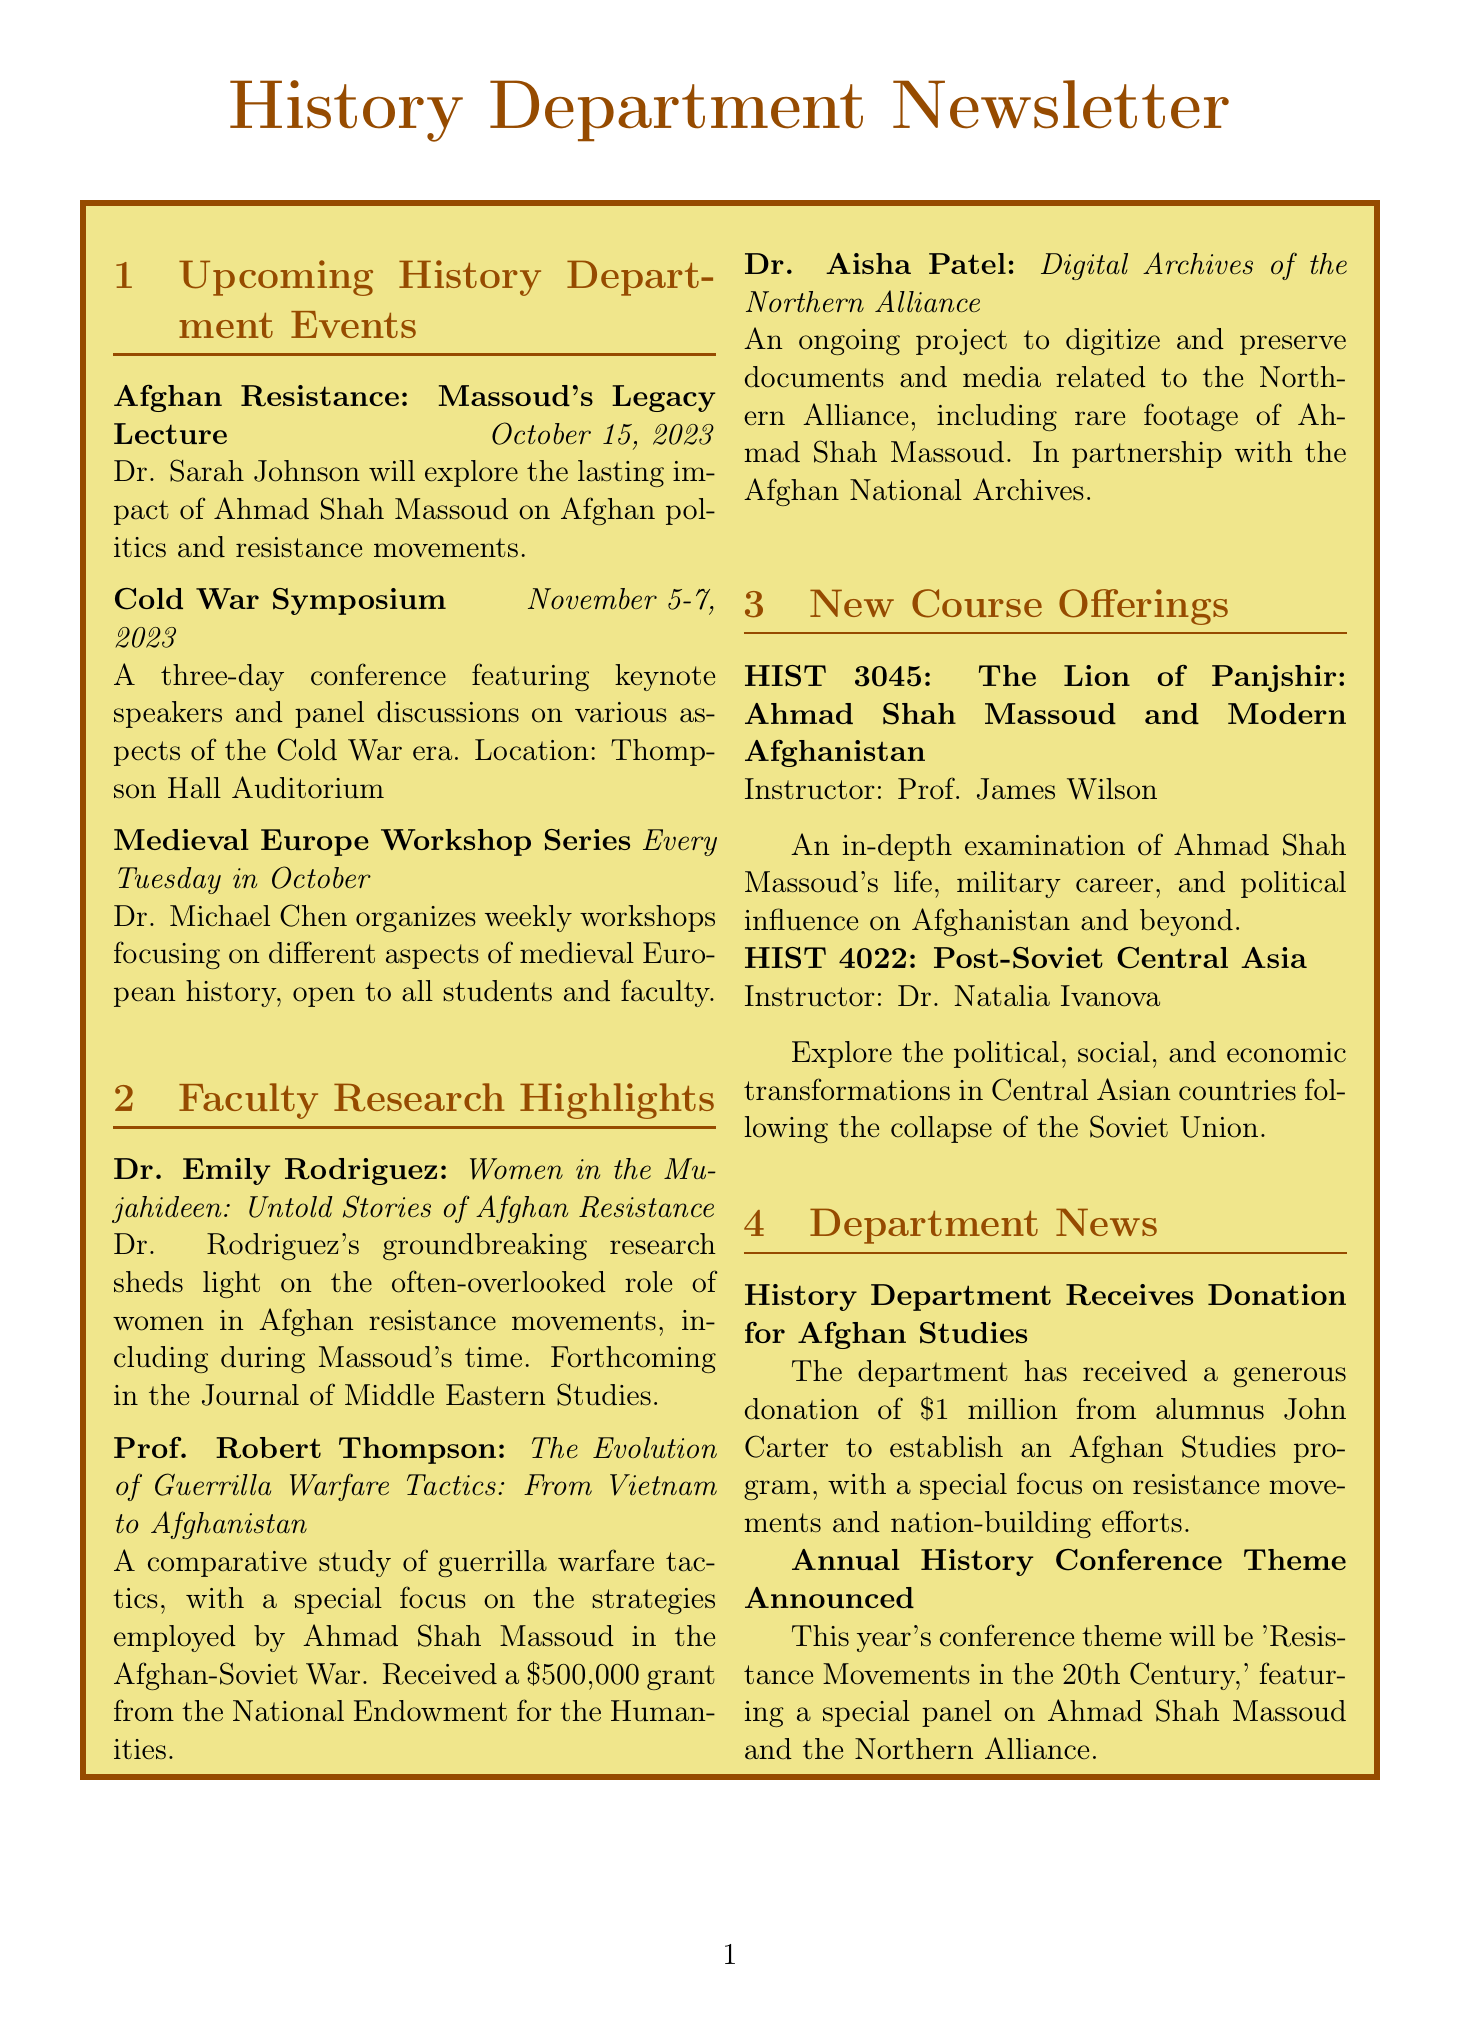What is the date of the Afghan Resistance lecture? The date for the Afghan Resistance lecture can be found under Upcoming History Department Events, specifically listed as October 15, 2023.
Answer: October 15, 2023 Who is the speaker for the Afghan Resistance lecture? The speaker's name for the Afghan Resistance lecture is mentioned directly in the event description.
Answer: Dr. Sarah Johnson What is Dr. Emily Rodriguez's research project title? The project title of Dr. Rodriguez's research is stated under Faculty Research Highlights.
Answer: Women in the Mujahideen: Untold Stories of Afghan Resistance How much funding did Prof. Robert Thompson receive for his project? The funding amount for Prof. Thompson's project is specified in the description.
Answer: $500,000 When does the Medieval Europe Workshop Series take place? The schedule for the Medieval Europe Workshop Series is detailed under the Upcoming History Department Events section.
Answer: Every Tuesday in October What is the theme of this year's annual history conference? The theme for the annual history conference is mentioned in the Department News section.
Answer: Resistance Movements in the 20th Century What course code corresponds to the class about Ahmad Shah Massoud? The course code for the class focusing on Ahmad Shah Massoud is provided in the New Course Offerings section.
Answer: HIST 3045 What is the primary focus of the Afghan Studies program established by the department? The primary focus of the Afghan Studies program is outlined in the Department News section.
Answer: Resistance movements and nation-building efforts 